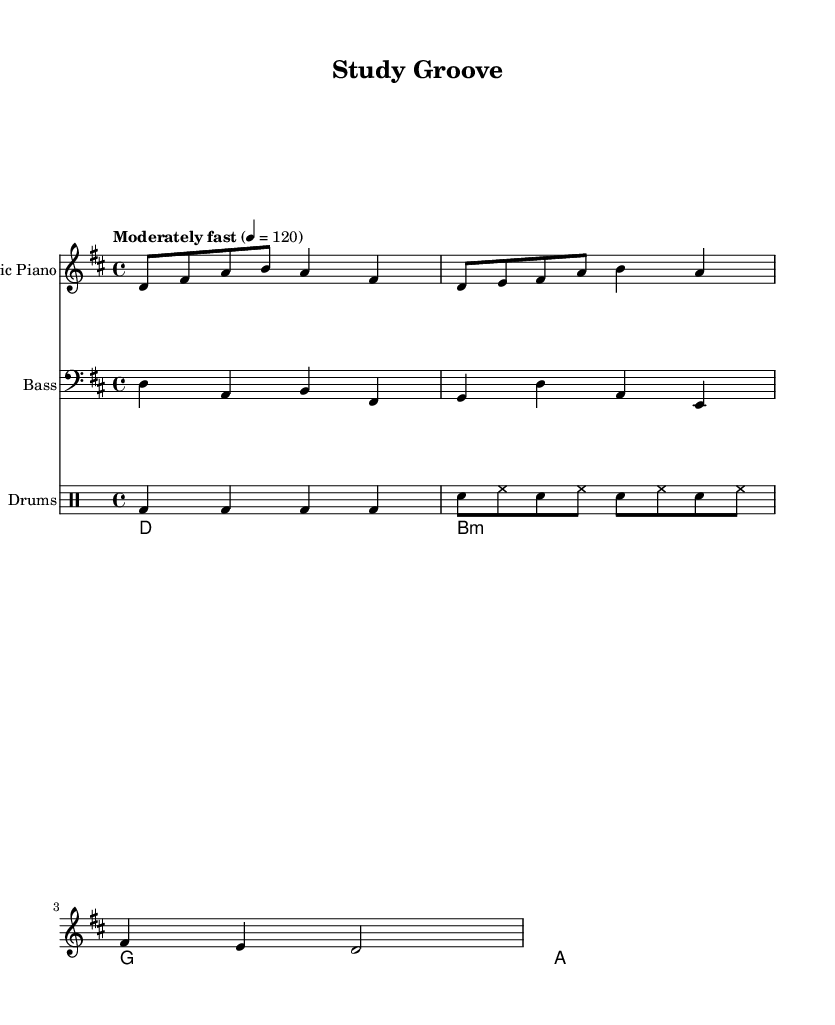What is the key signature of this music? The key signature is D major, which has two sharps (F# and C#). This can be identified at the beginning of the staff where the key signature is placed.
Answer: D major What is the time signature of this music? The time signature is 4/4, which indicates four beats per measure and is commonly used in upbeat songs. This is indicated at the beginning of the score.
Answer: 4/4 What is the tempo marking for this piece? The tempo marking indicates "Moderately fast" with a tempo of quarter note = 120 beats per minute, which sets a lively and energetic pace.
Answer: Moderately fast How many measures are in the electric piano part? There are four measures in the electric piano part, which can be counted by identifying the vertical lines separating each measure within the staff.
Answer: 4 What type of chords are used in the rhythm guitar part? The rhythm guitar part uses major chords (D major, B minor, G major, A major), indicated by the chord names above the staff.
Answer: Major chords What rhythmic value predominates in the drums part? The predominant rhythmic value in the drums part is the quarter note, as seen in the bass drum notation appearing four times in each measure.
Answer: Quarter note Which instrument plays the bass line? The bass line is played by the bass guitar, which is indicated on the staff with a clef symbol for bass instruments.
Answer: Bass guitar 